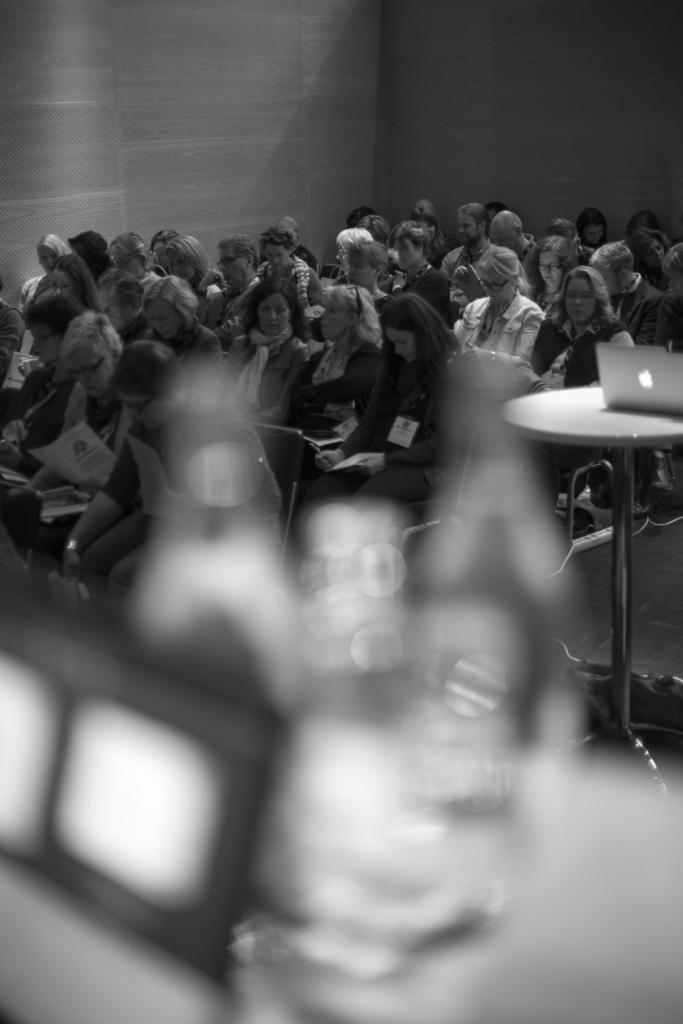How many people are in the image? There is a group of people in the image. What are the people doing in the image? The people are sitting on chairs and having a conversation. What device can be seen in the image? There is a laptop in the image. Where is the laptop located in the image? The laptop is placed on a table. On which side of the image is the table located? The table is on the right side of the image. What type of hook is being used to hold the beetle in the image? There is no hook or beetle present in the image. 